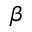Convert formula to latex. <formula><loc_0><loc_0><loc_500><loc_500>\beta</formula> 